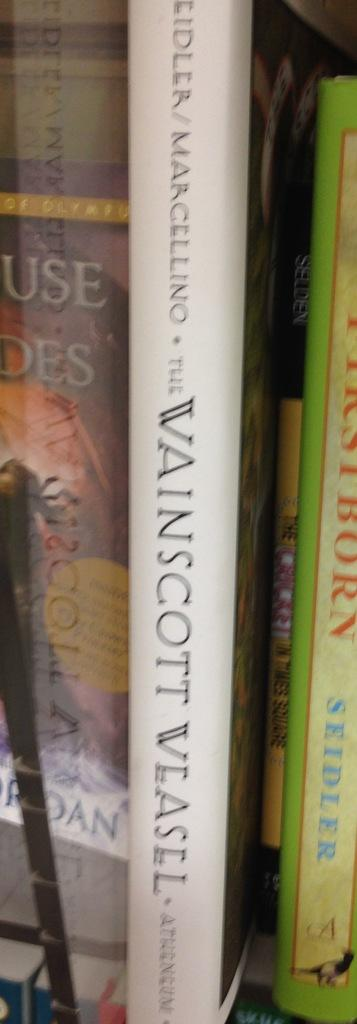<image>
Provide a brief description of the given image. A book standing upright titled The Wainscott Weasel. 